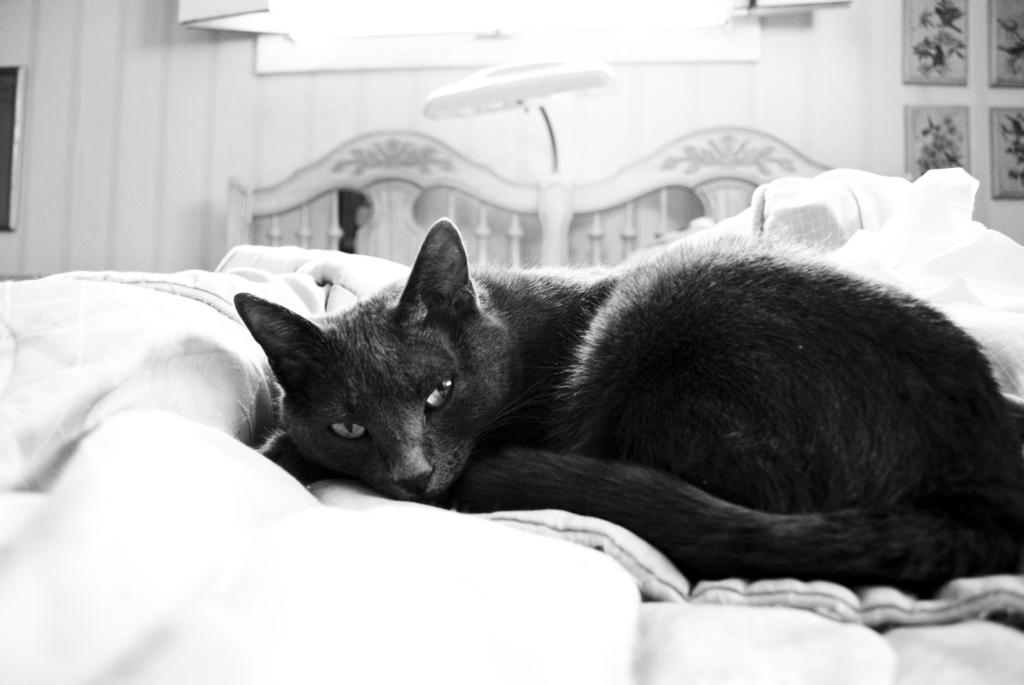What type of animal is in the image? There is a black color cat in the image. What is the cat doing in the image? The cat is sleeping. What is the color of the bed sheet in the image? The bed sheet is white in color. Where is the bed sheet located in the image? The bed sheet is placed on a bed. What can be seen in the background of the image? There is a wall, a frame, and a light in the background of the image. What type of square object can be seen in the image? There is no square object present in the image. What day of the week is the cat sleeping on? The day of the week is not mentioned or visible in the image. 